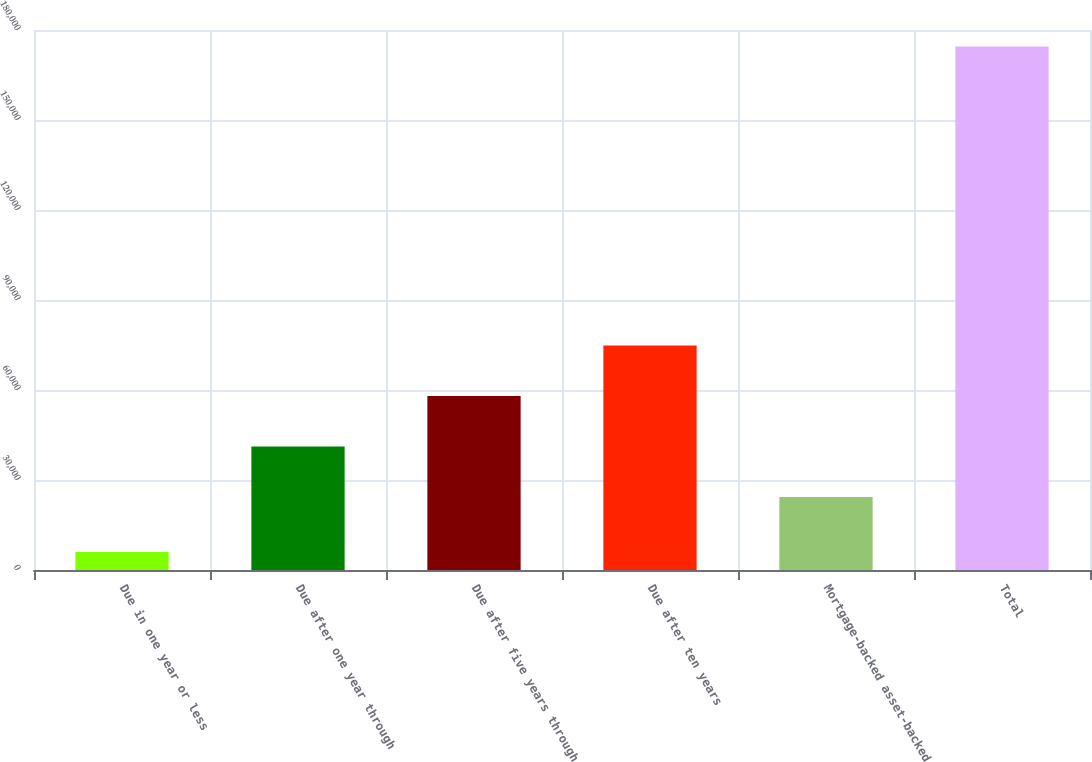Convert chart. <chart><loc_0><loc_0><loc_500><loc_500><bar_chart><fcel>Due in one year or less<fcel>Due after one year through<fcel>Due after five years through<fcel>Due after ten years<fcel>Mortgage-backed asset-backed<fcel>Total<nl><fcel>6023<fcel>41165<fcel>58011<fcel>74857<fcel>24319<fcel>174483<nl></chart> 